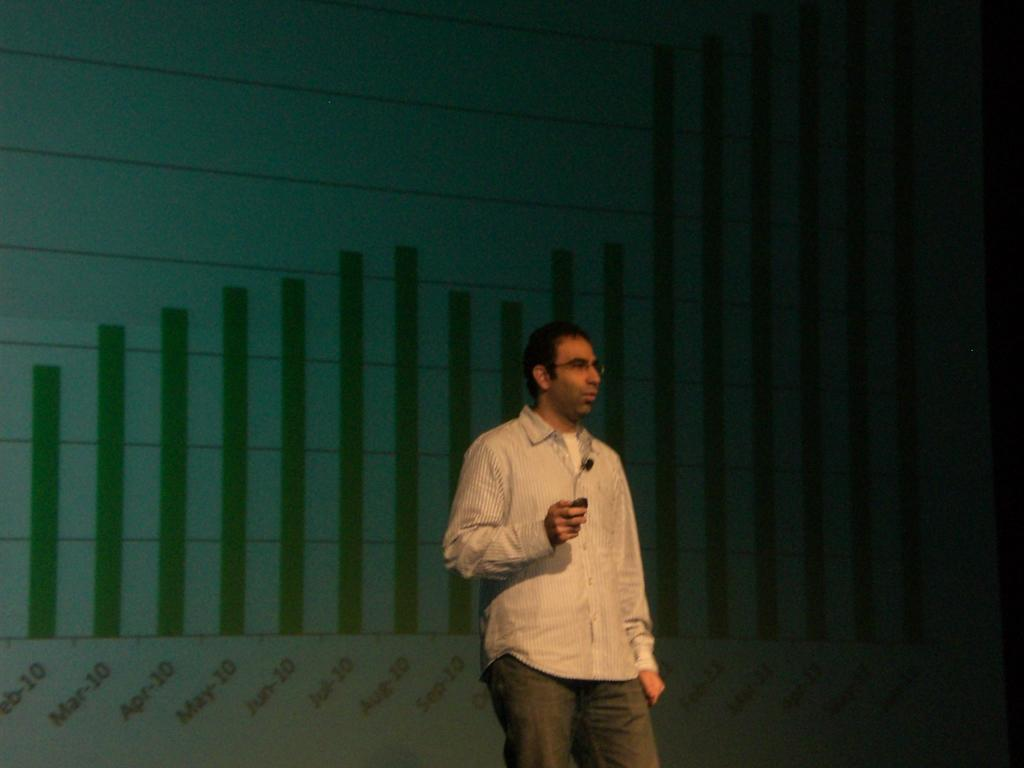What is the primary subject of the image? There is a person standing in the image. What is the person holding in the image? The person is holding an object. Can you describe the background of the image? There is a screen visible in the background of the image. How does the person twist the spoon in the image? There is no spoon present in the image, so the person cannot twist a spoon. 